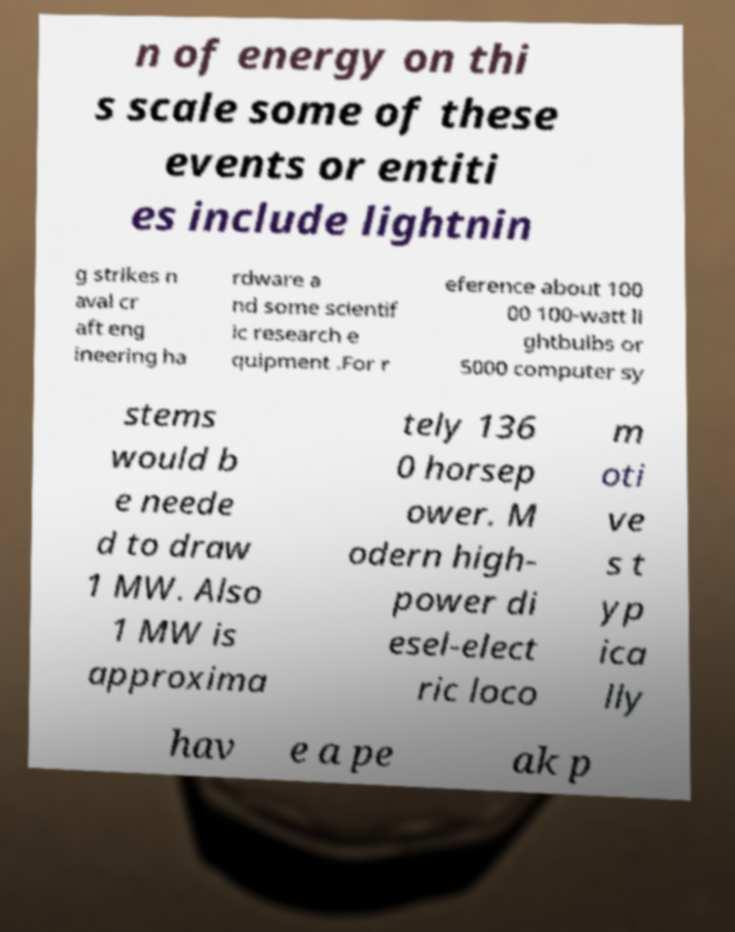I need the written content from this picture converted into text. Can you do that? n of energy on thi s scale some of these events or entiti es include lightnin g strikes n aval cr aft eng ineering ha rdware a nd some scientif ic research e quipment .For r eference about 100 00 100-watt li ghtbulbs or 5000 computer sy stems would b e neede d to draw 1 MW. Also 1 MW is approxima tely 136 0 horsep ower. M odern high- power di esel-elect ric loco m oti ve s t yp ica lly hav e a pe ak p 